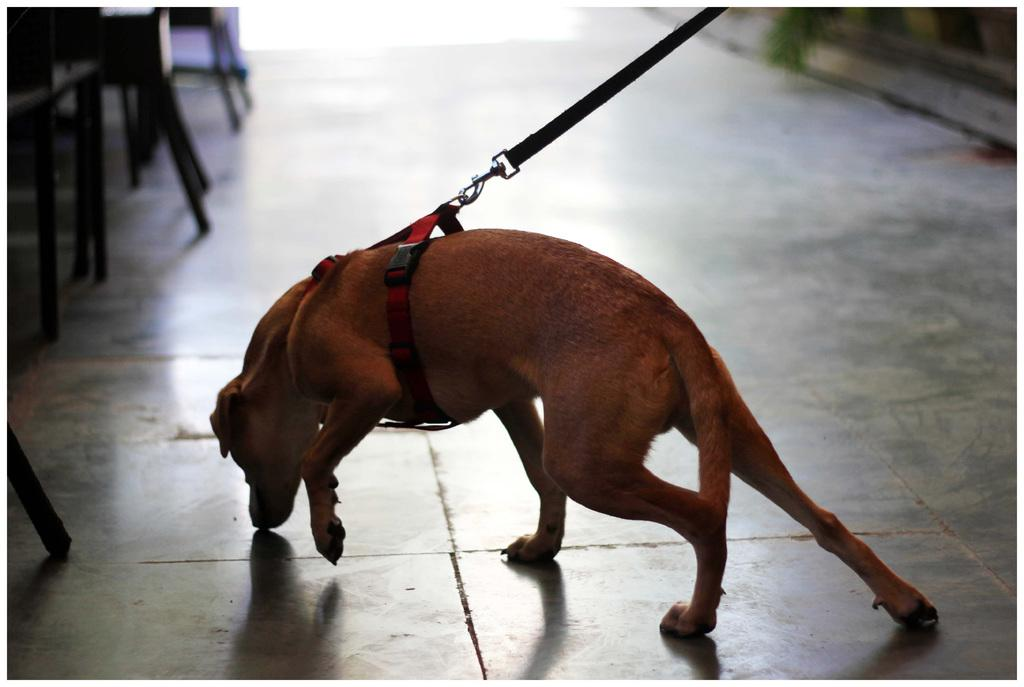What type of animal is in the picture? There is a dog in the picture. How is the dog being controlled or restrained? The dog is tied to a tag. What is the person in the picture doing with the dog? It appears that a person is taking the dog. What type of furniture is on the left side of the picture? There are chairs and tables on the left side of the picture. What type of apple is being used as a prop in the picture? There is no apple present in the picture; it features a dog tied to a tag and a person taking the dog. How many bubbles can be seen floating around the dog in the picture? There are no bubbles present in the picture; it features a dog tied to a tag and a person taking the dog. 